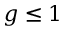<formula> <loc_0><loc_0><loc_500><loc_500>g \leq 1</formula> 